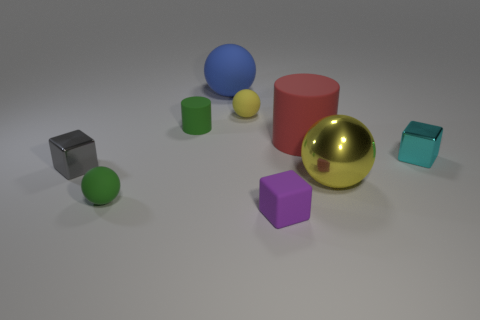Subtract all gray metal cubes. How many cubes are left? 2 Subtract all gray blocks. How many blocks are left? 2 Subtract 1 balls. How many balls are left? 3 Subtract all spheres. How many objects are left? 5 Subtract all rubber cylinders. Subtract all purple cubes. How many objects are left? 6 Add 7 small balls. How many small balls are left? 9 Add 3 tiny gray metal cylinders. How many tiny gray metal cylinders exist? 3 Subtract 0 red cubes. How many objects are left? 9 Subtract all blue spheres. Subtract all yellow blocks. How many spheres are left? 3 Subtract all yellow spheres. How many blue cylinders are left? 0 